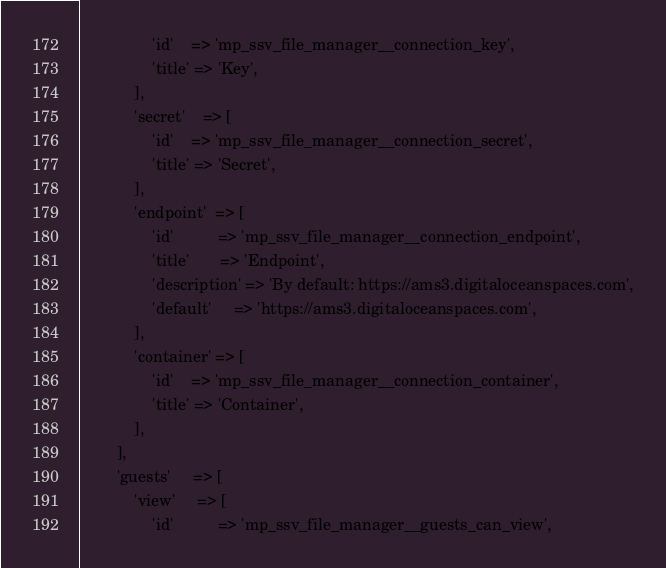<code> <loc_0><loc_0><loc_500><loc_500><_PHP_>                'id'    => 'mp_ssv_file_manager__connection_key',
                'title' => 'Key',
            ],
            'secret'    => [
                'id'    => 'mp_ssv_file_manager__connection_secret',
                'title' => 'Secret',
            ],
            'endpoint'  => [
                'id'          => 'mp_ssv_file_manager__connection_endpoint',
                'title'       => 'Endpoint',
                'description' => 'By default: https://ams3.digitaloceanspaces.com',
                'default'     => 'https://ams3.digitaloceanspaces.com',
            ],
            'container' => [
                'id'    => 'mp_ssv_file_manager__connection_container',
                'title' => 'Container',
            ],
        ],
        'guests'     => [
            'view'     => [
                'id'          => 'mp_ssv_file_manager__guests_can_view',</code> 